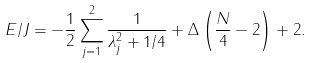Convert formula to latex. <formula><loc_0><loc_0><loc_500><loc_500>E / J = - \frac { 1 } { 2 } \sum _ { j = 1 } ^ { 2 } \frac { 1 } { \lambda ^ { 2 } _ { j } + 1 / 4 } + \Delta \left ( \frac { N } { 4 } - 2 \right ) + 2 .</formula> 